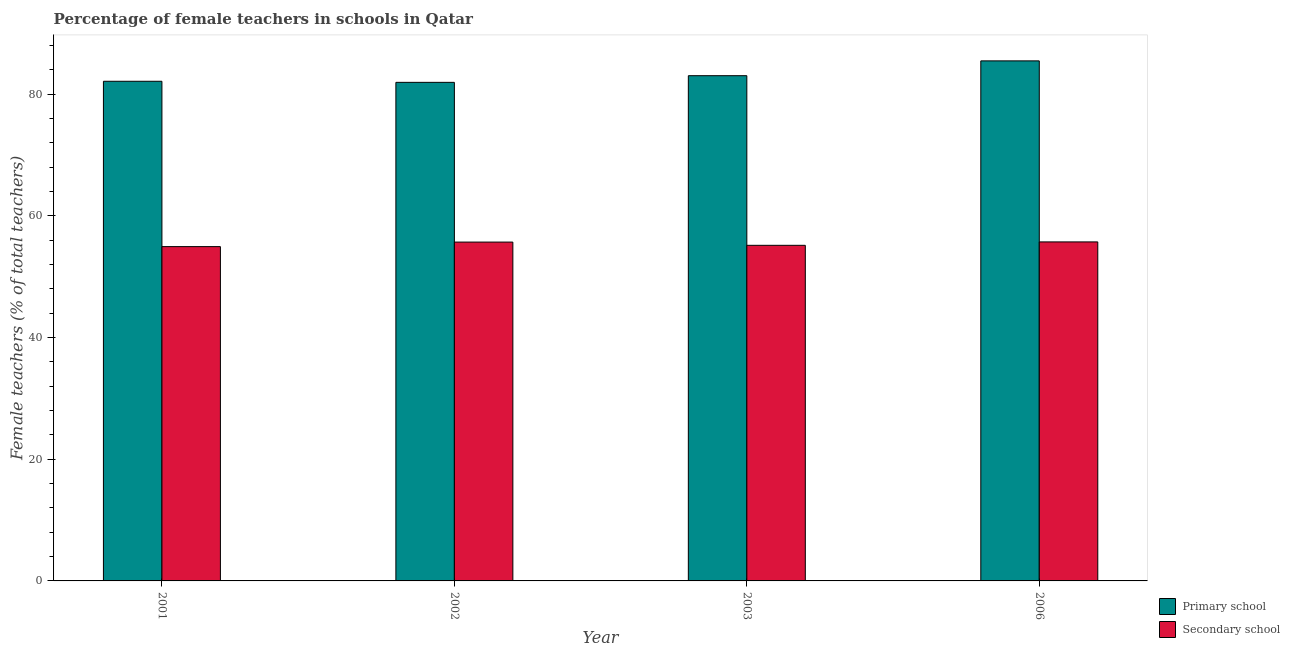How many different coloured bars are there?
Offer a very short reply. 2. How many groups of bars are there?
Ensure brevity in your answer.  4. Are the number of bars per tick equal to the number of legend labels?
Your answer should be compact. Yes. Are the number of bars on each tick of the X-axis equal?
Make the answer very short. Yes. What is the label of the 4th group of bars from the left?
Make the answer very short. 2006. What is the percentage of female teachers in secondary schools in 2003?
Make the answer very short. 55.17. Across all years, what is the maximum percentage of female teachers in secondary schools?
Your answer should be compact. 55.73. Across all years, what is the minimum percentage of female teachers in primary schools?
Give a very brief answer. 81.97. In which year was the percentage of female teachers in secondary schools maximum?
Offer a terse response. 2006. In which year was the percentage of female teachers in primary schools minimum?
Offer a very short reply. 2002. What is the total percentage of female teachers in primary schools in the graph?
Keep it short and to the point. 332.66. What is the difference between the percentage of female teachers in secondary schools in 2002 and that in 2006?
Provide a succinct answer. -0.03. What is the difference between the percentage of female teachers in secondary schools in 2003 and the percentage of female teachers in primary schools in 2006?
Provide a succinct answer. -0.56. What is the average percentage of female teachers in primary schools per year?
Give a very brief answer. 83.16. In the year 2006, what is the difference between the percentage of female teachers in secondary schools and percentage of female teachers in primary schools?
Your response must be concise. 0. What is the ratio of the percentage of female teachers in secondary schools in 2001 to that in 2002?
Provide a succinct answer. 0.99. Is the percentage of female teachers in primary schools in 2001 less than that in 2003?
Provide a succinct answer. Yes. Is the difference between the percentage of female teachers in secondary schools in 2001 and 2003 greater than the difference between the percentage of female teachers in primary schools in 2001 and 2003?
Provide a short and direct response. No. What is the difference between the highest and the second highest percentage of female teachers in secondary schools?
Keep it short and to the point. 0.03. What is the difference between the highest and the lowest percentage of female teachers in primary schools?
Keep it short and to the point. 3.53. In how many years, is the percentage of female teachers in primary schools greater than the average percentage of female teachers in primary schools taken over all years?
Ensure brevity in your answer.  1. What does the 2nd bar from the left in 2001 represents?
Provide a short and direct response. Secondary school. What does the 1st bar from the right in 2001 represents?
Keep it short and to the point. Secondary school. Are all the bars in the graph horizontal?
Make the answer very short. No. How many years are there in the graph?
Your response must be concise. 4. Where does the legend appear in the graph?
Provide a short and direct response. Bottom right. How many legend labels are there?
Provide a succinct answer. 2. What is the title of the graph?
Provide a succinct answer. Percentage of female teachers in schools in Qatar. Does "Pregnant women" appear as one of the legend labels in the graph?
Provide a succinct answer. No. What is the label or title of the X-axis?
Provide a short and direct response. Year. What is the label or title of the Y-axis?
Your answer should be compact. Female teachers (% of total teachers). What is the Female teachers (% of total teachers) of Primary school in 2001?
Your response must be concise. 82.14. What is the Female teachers (% of total teachers) of Secondary school in 2001?
Give a very brief answer. 54.96. What is the Female teachers (% of total teachers) of Primary school in 2002?
Ensure brevity in your answer.  81.97. What is the Female teachers (% of total teachers) in Secondary school in 2002?
Offer a terse response. 55.7. What is the Female teachers (% of total teachers) of Primary school in 2003?
Your answer should be compact. 83.06. What is the Female teachers (% of total teachers) in Secondary school in 2003?
Your answer should be compact. 55.17. What is the Female teachers (% of total teachers) of Primary school in 2006?
Your answer should be very brief. 85.49. What is the Female teachers (% of total teachers) in Secondary school in 2006?
Offer a terse response. 55.73. Across all years, what is the maximum Female teachers (% of total teachers) of Primary school?
Offer a very short reply. 85.49. Across all years, what is the maximum Female teachers (% of total teachers) of Secondary school?
Your answer should be compact. 55.73. Across all years, what is the minimum Female teachers (% of total teachers) of Primary school?
Make the answer very short. 81.97. Across all years, what is the minimum Female teachers (% of total teachers) of Secondary school?
Give a very brief answer. 54.96. What is the total Female teachers (% of total teachers) of Primary school in the graph?
Keep it short and to the point. 332.66. What is the total Female teachers (% of total teachers) in Secondary school in the graph?
Offer a very short reply. 221.57. What is the difference between the Female teachers (% of total teachers) of Primary school in 2001 and that in 2002?
Your answer should be compact. 0.18. What is the difference between the Female teachers (% of total teachers) in Secondary school in 2001 and that in 2002?
Give a very brief answer. -0.74. What is the difference between the Female teachers (% of total teachers) in Primary school in 2001 and that in 2003?
Offer a very short reply. -0.92. What is the difference between the Female teachers (% of total teachers) in Secondary school in 2001 and that in 2003?
Offer a very short reply. -0.21. What is the difference between the Female teachers (% of total teachers) of Primary school in 2001 and that in 2006?
Your answer should be very brief. -3.35. What is the difference between the Female teachers (% of total teachers) of Secondary school in 2001 and that in 2006?
Provide a short and direct response. -0.77. What is the difference between the Female teachers (% of total teachers) in Primary school in 2002 and that in 2003?
Your answer should be compact. -1.09. What is the difference between the Female teachers (% of total teachers) of Secondary school in 2002 and that in 2003?
Give a very brief answer. 0.53. What is the difference between the Female teachers (% of total teachers) in Primary school in 2002 and that in 2006?
Make the answer very short. -3.53. What is the difference between the Female teachers (% of total teachers) of Secondary school in 2002 and that in 2006?
Your answer should be compact. -0.03. What is the difference between the Female teachers (% of total teachers) of Primary school in 2003 and that in 2006?
Give a very brief answer. -2.44. What is the difference between the Female teachers (% of total teachers) of Secondary school in 2003 and that in 2006?
Your answer should be very brief. -0.56. What is the difference between the Female teachers (% of total teachers) of Primary school in 2001 and the Female teachers (% of total teachers) of Secondary school in 2002?
Provide a succinct answer. 26.44. What is the difference between the Female teachers (% of total teachers) of Primary school in 2001 and the Female teachers (% of total teachers) of Secondary school in 2003?
Your answer should be compact. 26.97. What is the difference between the Female teachers (% of total teachers) in Primary school in 2001 and the Female teachers (% of total teachers) in Secondary school in 2006?
Your answer should be compact. 26.41. What is the difference between the Female teachers (% of total teachers) in Primary school in 2002 and the Female teachers (% of total teachers) in Secondary school in 2003?
Your answer should be very brief. 26.79. What is the difference between the Female teachers (% of total teachers) in Primary school in 2002 and the Female teachers (% of total teachers) in Secondary school in 2006?
Your answer should be compact. 26.23. What is the difference between the Female teachers (% of total teachers) in Primary school in 2003 and the Female teachers (% of total teachers) in Secondary school in 2006?
Provide a short and direct response. 27.32. What is the average Female teachers (% of total teachers) of Primary school per year?
Provide a short and direct response. 83.16. What is the average Female teachers (% of total teachers) of Secondary school per year?
Give a very brief answer. 55.39. In the year 2001, what is the difference between the Female teachers (% of total teachers) of Primary school and Female teachers (% of total teachers) of Secondary school?
Provide a succinct answer. 27.18. In the year 2002, what is the difference between the Female teachers (% of total teachers) in Primary school and Female teachers (% of total teachers) in Secondary school?
Offer a terse response. 26.26. In the year 2003, what is the difference between the Female teachers (% of total teachers) of Primary school and Female teachers (% of total teachers) of Secondary school?
Provide a succinct answer. 27.89. In the year 2006, what is the difference between the Female teachers (% of total teachers) of Primary school and Female teachers (% of total teachers) of Secondary school?
Your answer should be compact. 29.76. What is the ratio of the Female teachers (% of total teachers) of Primary school in 2001 to that in 2002?
Keep it short and to the point. 1. What is the ratio of the Female teachers (% of total teachers) in Secondary school in 2001 to that in 2002?
Offer a very short reply. 0.99. What is the ratio of the Female teachers (% of total teachers) of Secondary school in 2001 to that in 2003?
Offer a very short reply. 1. What is the ratio of the Female teachers (% of total teachers) in Primary school in 2001 to that in 2006?
Your answer should be compact. 0.96. What is the ratio of the Female teachers (% of total teachers) of Secondary school in 2001 to that in 2006?
Provide a short and direct response. 0.99. What is the ratio of the Female teachers (% of total teachers) of Secondary school in 2002 to that in 2003?
Provide a succinct answer. 1.01. What is the ratio of the Female teachers (% of total teachers) in Primary school in 2002 to that in 2006?
Give a very brief answer. 0.96. What is the ratio of the Female teachers (% of total teachers) in Secondary school in 2002 to that in 2006?
Provide a short and direct response. 1. What is the ratio of the Female teachers (% of total teachers) of Primary school in 2003 to that in 2006?
Provide a short and direct response. 0.97. What is the difference between the highest and the second highest Female teachers (% of total teachers) of Primary school?
Keep it short and to the point. 2.44. What is the difference between the highest and the second highest Female teachers (% of total teachers) in Secondary school?
Give a very brief answer. 0.03. What is the difference between the highest and the lowest Female teachers (% of total teachers) in Primary school?
Make the answer very short. 3.53. What is the difference between the highest and the lowest Female teachers (% of total teachers) in Secondary school?
Offer a very short reply. 0.77. 